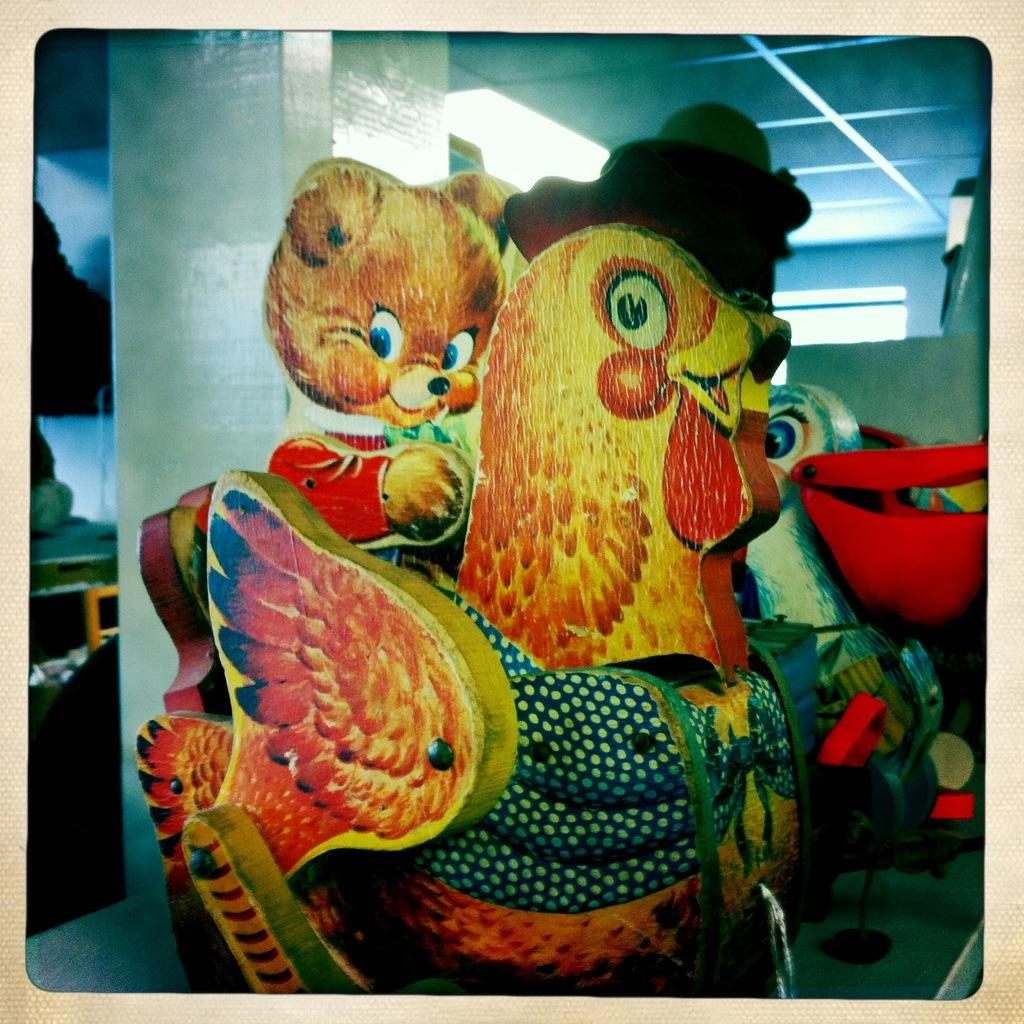What objects are on the table in the image? There are toys on a table in the image. What can be seen in the background of the image? There is a pillar in the background of the image. What is above the table in the image? There is a ceiling visible in the image. What provides illumination in the image? There are lights in the image. How many hands are visible in the image? There are no hands visible in the image. What day of the week is depicted in the image? The image does not depict a specific day of the week. 